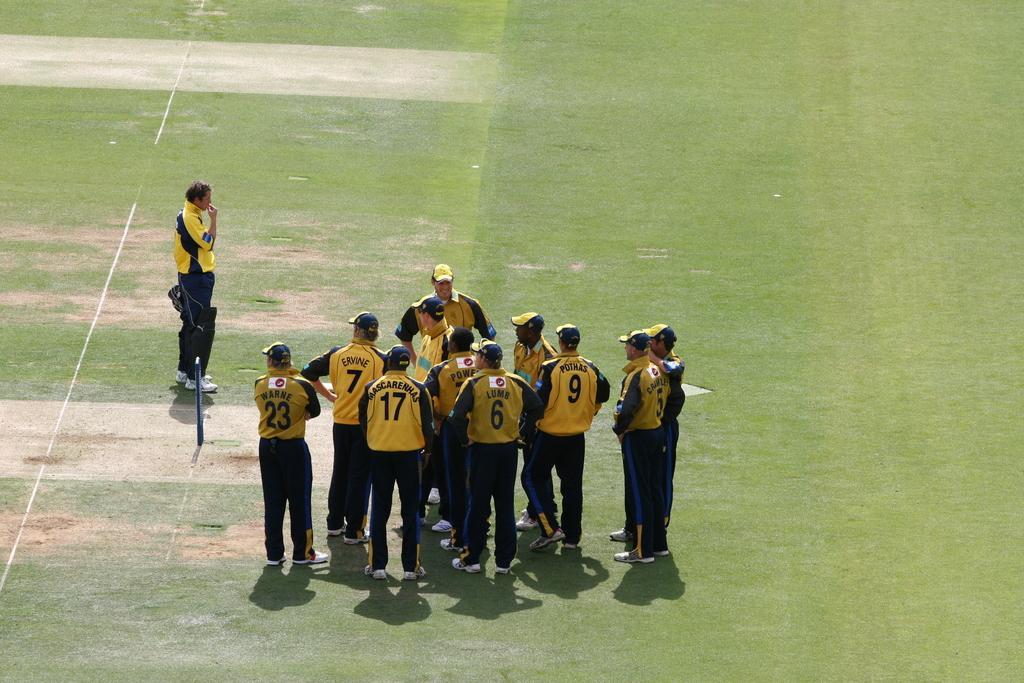Could you give a brief overview of what you see in this image? In this image I see men who are wearing jerseys which are of yellow and black in color and I see numbers and words written on their t-shirts and I see that all of them are wearing caps except this man and I see the pitch on which there are white lines and I see the wickets over here. 